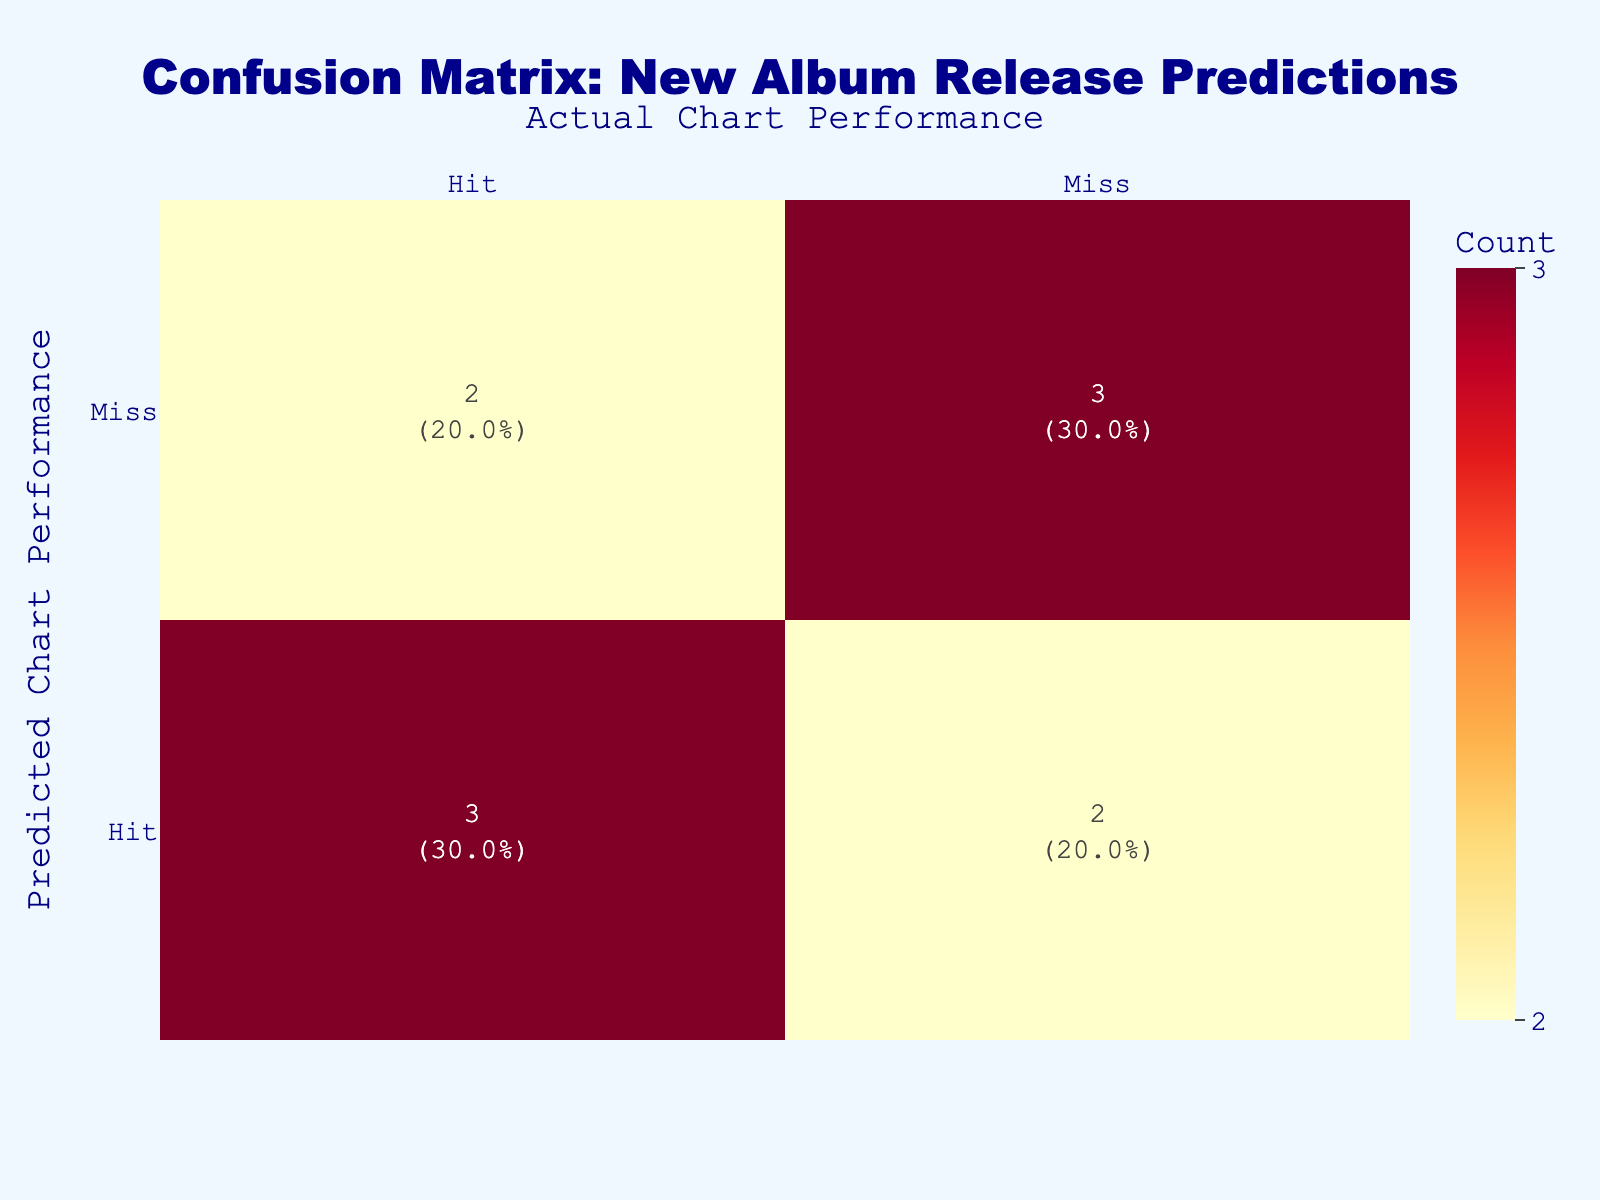What is the total number of albums predicted to hit the charts? There are 5 albums that have the predicted chart performance as "Hit," which are "Midnights," "Certified Lover Boy," "Positions," "Bayou," and "Donda."
Answer: 5 How many albums actually hit the charts? The actual chart performances that are marked as "Hit" include albums "Midnights," "30," "Positions," "Bayou," and "Divide." Counting these gives us a total of 5 albums that actually hit the charts.
Answer: 5 Is there any album that was predicted to hit but actually missed? The album "Certified Lover Boy" by Drake and "Donda" by Kanye West were both predicted to hit but actually missed. This makes the answer yes.
Answer: Yes What is the ratio of albums that were correctly predicted as a hit to those that were incorrectly predicted as a hit? There are 4 albums that were correctly predicted as a hit (Midnights, Positions, Bayou, and one count of the actuals from the Miss which is the album "30"). There are 3 albums that were incorrectly predicted as a hit (Certified Lover Boy and Donda) and one album that was predicted as a Miss but was an actual Hit (Divide). Hence, the total hits like this would mean: 4/3 = 1.33 (essentially rounding here we see there are more hits correctly predicted) implying the correct predictions outweigh the misses in this context.
Answer: 4:3 How many albums were both predicted and actually missed? Looking at the "Miss" category for both predicted and actual performances, the albums in that category are "Evermore," "Justice," and "Future Nostalgia," giving a total of 3 albums.
Answer: 3 Which artist had the album that was predicted to miss but actually hit? The artist is Ed Sheeran with the album "Divide." This is noted as a Miss for the predicted performance but was an actual hit chart-wise.
Answer: Ed Sheeran What percentage of albums that were predicted to hit actually hit? To find this, divide the number of albums that were correctly predicted to hit (4, which are Midnights, Positions, Bayou, and also adding Divide since it wasn't a Miss predicted), by the total number of albums predicted to hit, which is 7. The calculation is (4/7) * 100 = ~57.1%.
Answer: ~57.1% What is the combined total of albums that hit the charts, and those that missed based on prediction? The total for "Hit" is 5, and for "Miss" predictions, the remaining is 5 (from totals laid out above). So, total Hit + Miss = 5 + 5 = 10 albums.
Answer: 10 